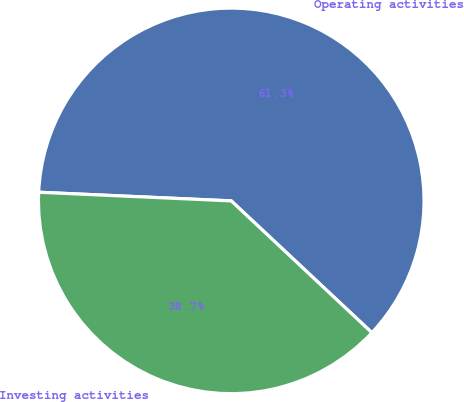<chart> <loc_0><loc_0><loc_500><loc_500><pie_chart><fcel>Operating activities<fcel>Investing activities<nl><fcel>61.27%<fcel>38.73%<nl></chart> 